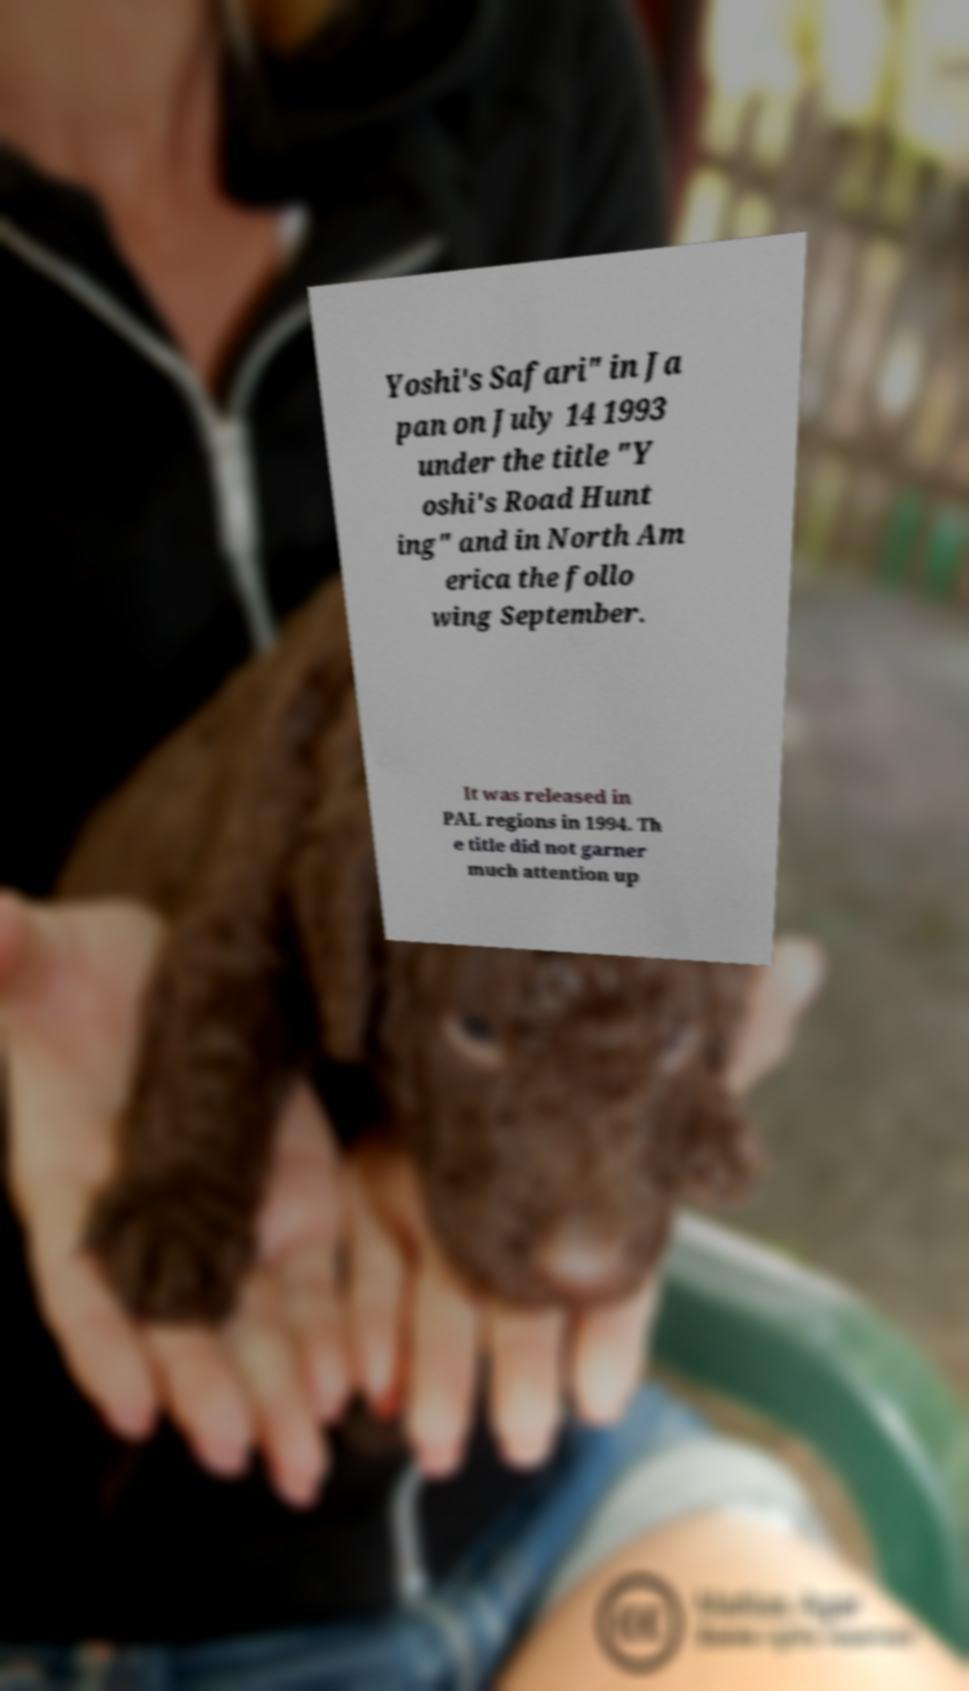Can you read and provide the text displayed in the image?This photo seems to have some interesting text. Can you extract and type it out for me? Yoshi's Safari" in Ja pan on July 14 1993 under the title "Y oshi's Road Hunt ing" and in North Am erica the follo wing September. It was released in PAL regions in 1994. Th e title did not garner much attention up 